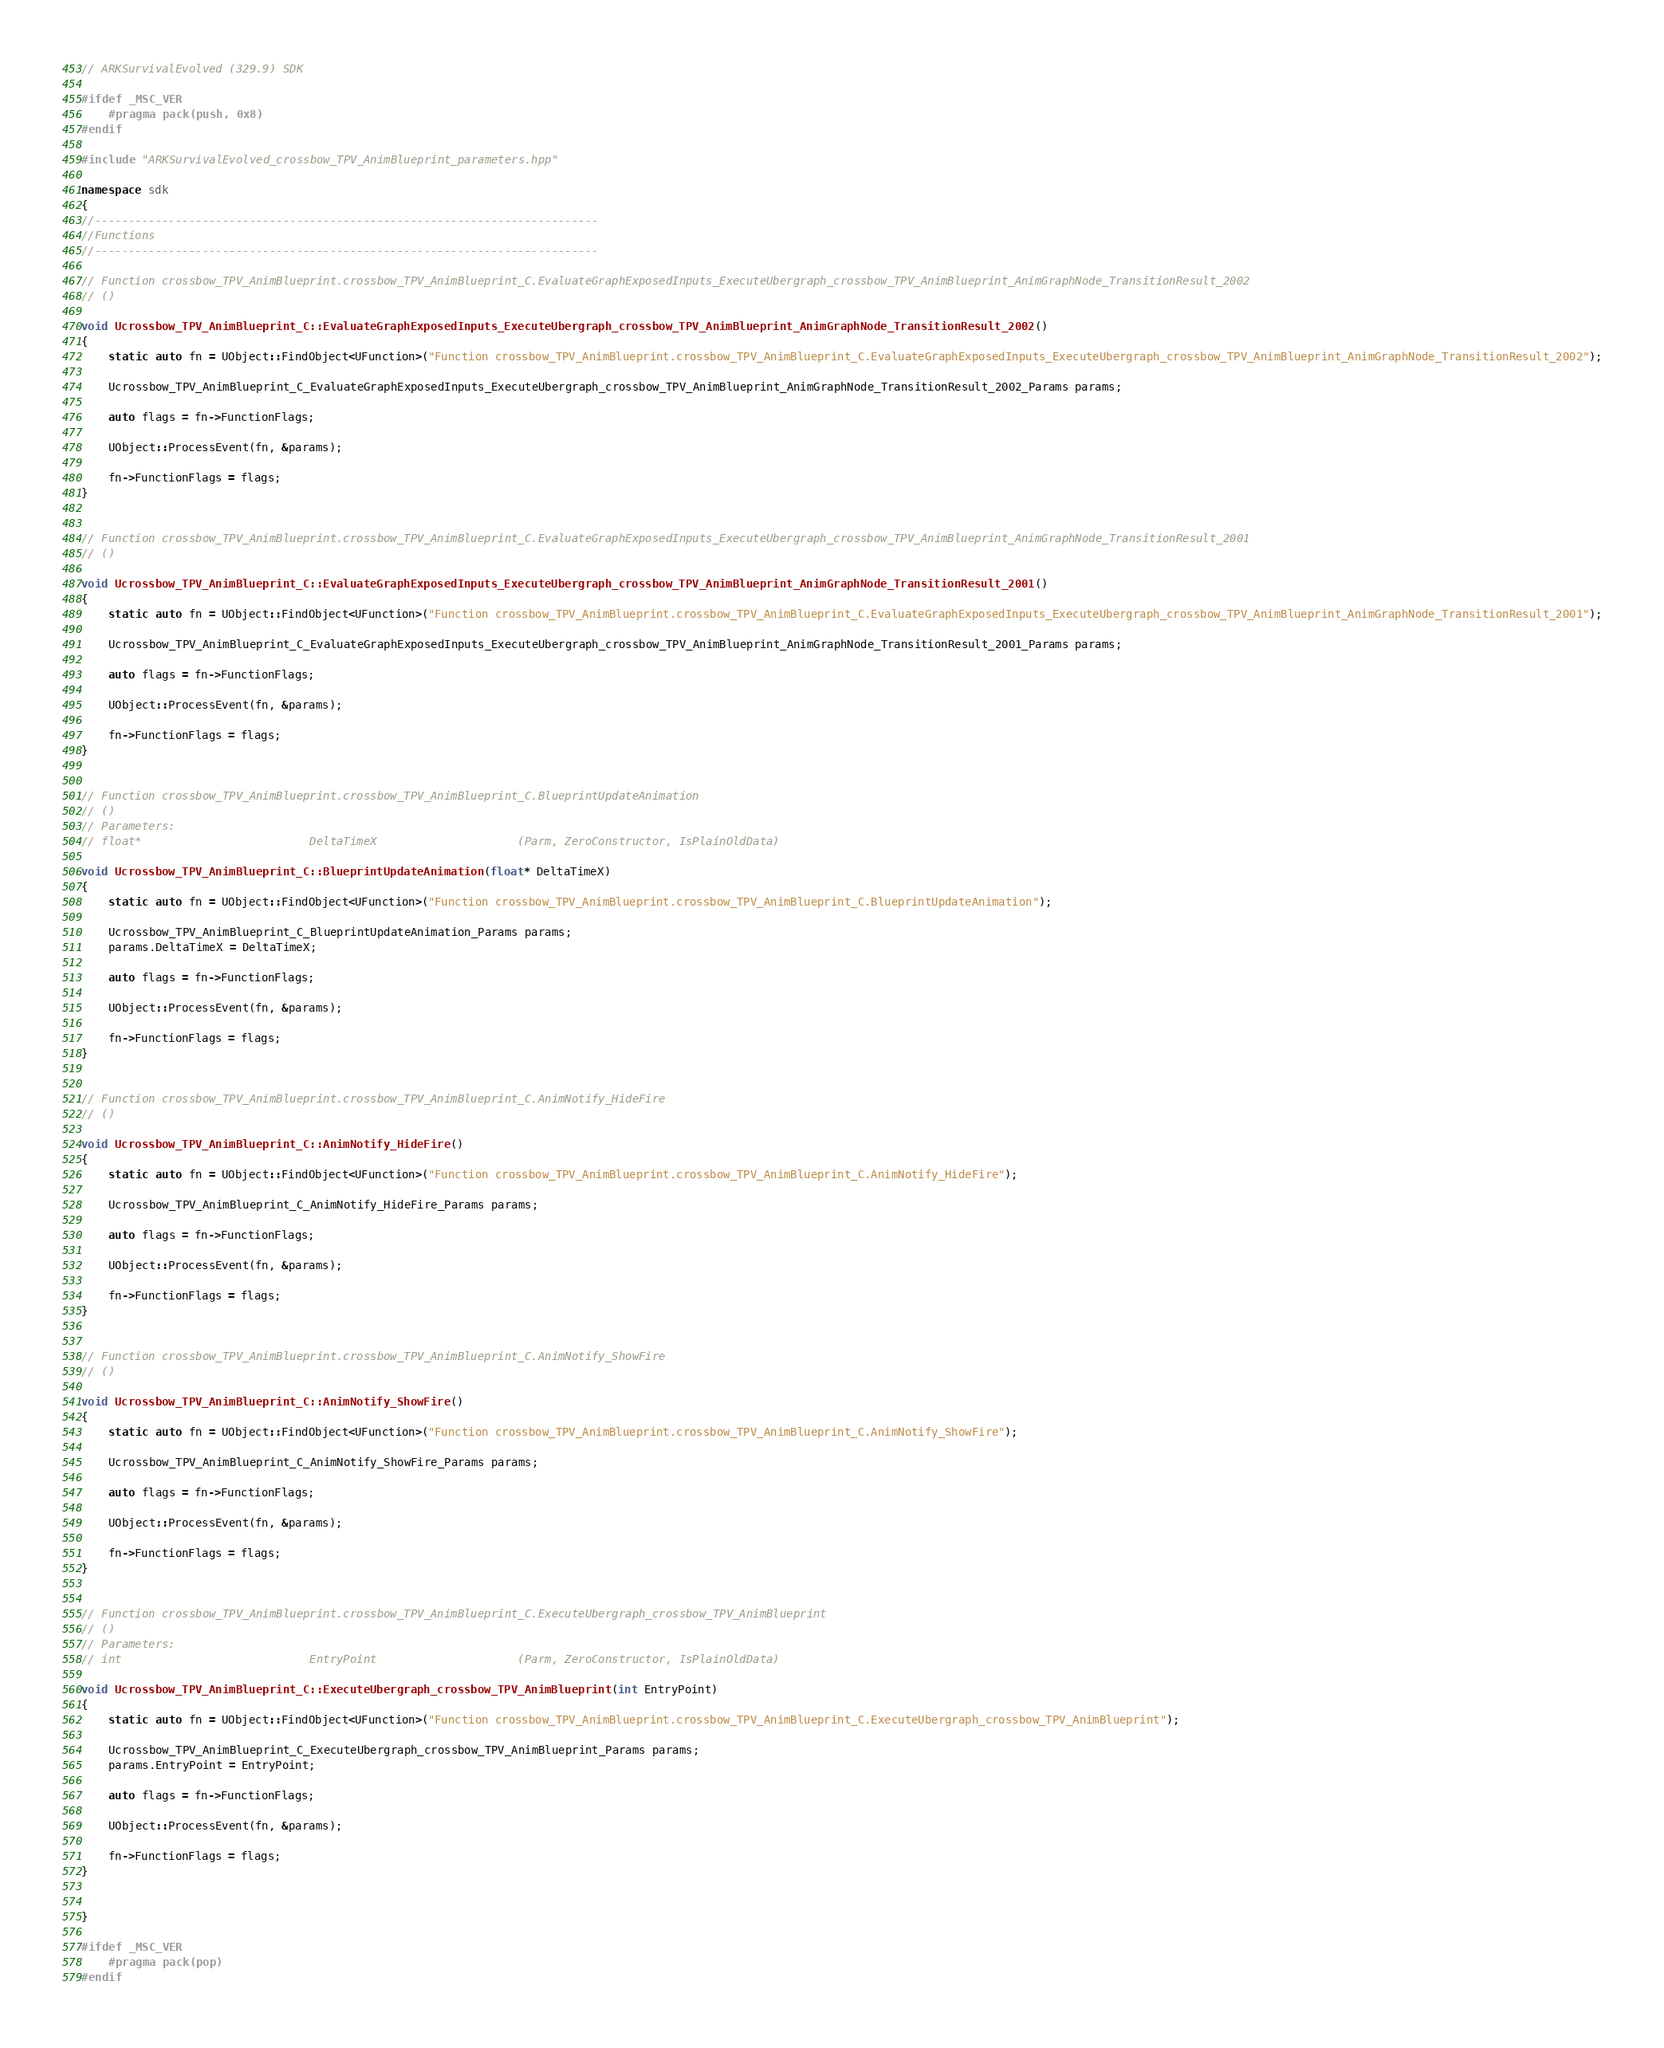<code> <loc_0><loc_0><loc_500><loc_500><_C++_>// ARKSurvivalEvolved (329.9) SDK

#ifdef _MSC_VER
	#pragma pack(push, 0x8)
#endif

#include "ARKSurvivalEvolved_crossbow_TPV_AnimBlueprint_parameters.hpp"

namespace sdk
{
//---------------------------------------------------------------------------
//Functions
//---------------------------------------------------------------------------

// Function crossbow_TPV_AnimBlueprint.crossbow_TPV_AnimBlueprint_C.EvaluateGraphExposedInputs_ExecuteUbergraph_crossbow_TPV_AnimBlueprint_AnimGraphNode_TransitionResult_2002
// ()

void Ucrossbow_TPV_AnimBlueprint_C::EvaluateGraphExposedInputs_ExecuteUbergraph_crossbow_TPV_AnimBlueprint_AnimGraphNode_TransitionResult_2002()
{
	static auto fn = UObject::FindObject<UFunction>("Function crossbow_TPV_AnimBlueprint.crossbow_TPV_AnimBlueprint_C.EvaluateGraphExposedInputs_ExecuteUbergraph_crossbow_TPV_AnimBlueprint_AnimGraphNode_TransitionResult_2002");

	Ucrossbow_TPV_AnimBlueprint_C_EvaluateGraphExposedInputs_ExecuteUbergraph_crossbow_TPV_AnimBlueprint_AnimGraphNode_TransitionResult_2002_Params params;

	auto flags = fn->FunctionFlags;

	UObject::ProcessEvent(fn, &params);

	fn->FunctionFlags = flags;
}


// Function crossbow_TPV_AnimBlueprint.crossbow_TPV_AnimBlueprint_C.EvaluateGraphExposedInputs_ExecuteUbergraph_crossbow_TPV_AnimBlueprint_AnimGraphNode_TransitionResult_2001
// ()

void Ucrossbow_TPV_AnimBlueprint_C::EvaluateGraphExposedInputs_ExecuteUbergraph_crossbow_TPV_AnimBlueprint_AnimGraphNode_TransitionResult_2001()
{
	static auto fn = UObject::FindObject<UFunction>("Function crossbow_TPV_AnimBlueprint.crossbow_TPV_AnimBlueprint_C.EvaluateGraphExposedInputs_ExecuteUbergraph_crossbow_TPV_AnimBlueprint_AnimGraphNode_TransitionResult_2001");

	Ucrossbow_TPV_AnimBlueprint_C_EvaluateGraphExposedInputs_ExecuteUbergraph_crossbow_TPV_AnimBlueprint_AnimGraphNode_TransitionResult_2001_Params params;

	auto flags = fn->FunctionFlags;

	UObject::ProcessEvent(fn, &params);

	fn->FunctionFlags = flags;
}


// Function crossbow_TPV_AnimBlueprint.crossbow_TPV_AnimBlueprint_C.BlueprintUpdateAnimation
// ()
// Parameters:
// float*                         DeltaTimeX                     (Parm, ZeroConstructor, IsPlainOldData)

void Ucrossbow_TPV_AnimBlueprint_C::BlueprintUpdateAnimation(float* DeltaTimeX)
{
	static auto fn = UObject::FindObject<UFunction>("Function crossbow_TPV_AnimBlueprint.crossbow_TPV_AnimBlueprint_C.BlueprintUpdateAnimation");

	Ucrossbow_TPV_AnimBlueprint_C_BlueprintUpdateAnimation_Params params;
	params.DeltaTimeX = DeltaTimeX;

	auto flags = fn->FunctionFlags;

	UObject::ProcessEvent(fn, &params);

	fn->FunctionFlags = flags;
}


// Function crossbow_TPV_AnimBlueprint.crossbow_TPV_AnimBlueprint_C.AnimNotify_HideFire
// ()

void Ucrossbow_TPV_AnimBlueprint_C::AnimNotify_HideFire()
{
	static auto fn = UObject::FindObject<UFunction>("Function crossbow_TPV_AnimBlueprint.crossbow_TPV_AnimBlueprint_C.AnimNotify_HideFire");

	Ucrossbow_TPV_AnimBlueprint_C_AnimNotify_HideFire_Params params;

	auto flags = fn->FunctionFlags;

	UObject::ProcessEvent(fn, &params);

	fn->FunctionFlags = flags;
}


// Function crossbow_TPV_AnimBlueprint.crossbow_TPV_AnimBlueprint_C.AnimNotify_ShowFire
// ()

void Ucrossbow_TPV_AnimBlueprint_C::AnimNotify_ShowFire()
{
	static auto fn = UObject::FindObject<UFunction>("Function crossbow_TPV_AnimBlueprint.crossbow_TPV_AnimBlueprint_C.AnimNotify_ShowFire");

	Ucrossbow_TPV_AnimBlueprint_C_AnimNotify_ShowFire_Params params;

	auto flags = fn->FunctionFlags;

	UObject::ProcessEvent(fn, &params);

	fn->FunctionFlags = flags;
}


// Function crossbow_TPV_AnimBlueprint.crossbow_TPV_AnimBlueprint_C.ExecuteUbergraph_crossbow_TPV_AnimBlueprint
// ()
// Parameters:
// int                            EntryPoint                     (Parm, ZeroConstructor, IsPlainOldData)

void Ucrossbow_TPV_AnimBlueprint_C::ExecuteUbergraph_crossbow_TPV_AnimBlueprint(int EntryPoint)
{
	static auto fn = UObject::FindObject<UFunction>("Function crossbow_TPV_AnimBlueprint.crossbow_TPV_AnimBlueprint_C.ExecuteUbergraph_crossbow_TPV_AnimBlueprint");

	Ucrossbow_TPV_AnimBlueprint_C_ExecuteUbergraph_crossbow_TPV_AnimBlueprint_Params params;
	params.EntryPoint = EntryPoint;

	auto flags = fn->FunctionFlags;

	UObject::ProcessEvent(fn, &params);

	fn->FunctionFlags = flags;
}


}

#ifdef _MSC_VER
	#pragma pack(pop)
#endif
</code> 